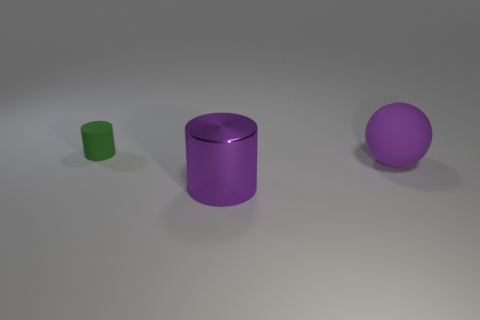There is a big cylinder that is the same color as the large sphere; what material is it?
Offer a very short reply. Metal. Is the material of the big cylinder the same as the small thing left of the rubber sphere?
Make the answer very short. No. What is the color of the small thing?
Provide a succinct answer. Green. There is a matte thing in front of the cylinder that is behind the rubber thing that is in front of the small rubber cylinder; what color is it?
Give a very brief answer. Purple. Is the shape of the purple matte thing the same as the object behind the large purple matte object?
Your answer should be very brief. No. What is the color of the thing that is right of the tiny cylinder and behind the shiny cylinder?
Give a very brief answer. Purple. Is there another purple object that has the same shape as the purple rubber thing?
Offer a terse response. No. Do the tiny thing and the metal object have the same color?
Offer a terse response. No. There is a big purple thing on the right side of the big purple metallic object; is there a big purple metallic thing that is right of it?
Provide a short and direct response. No. What number of things are things that are behind the big purple matte sphere or matte things that are on the left side of the purple rubber thing?
Your answer should be very brief. 1. 